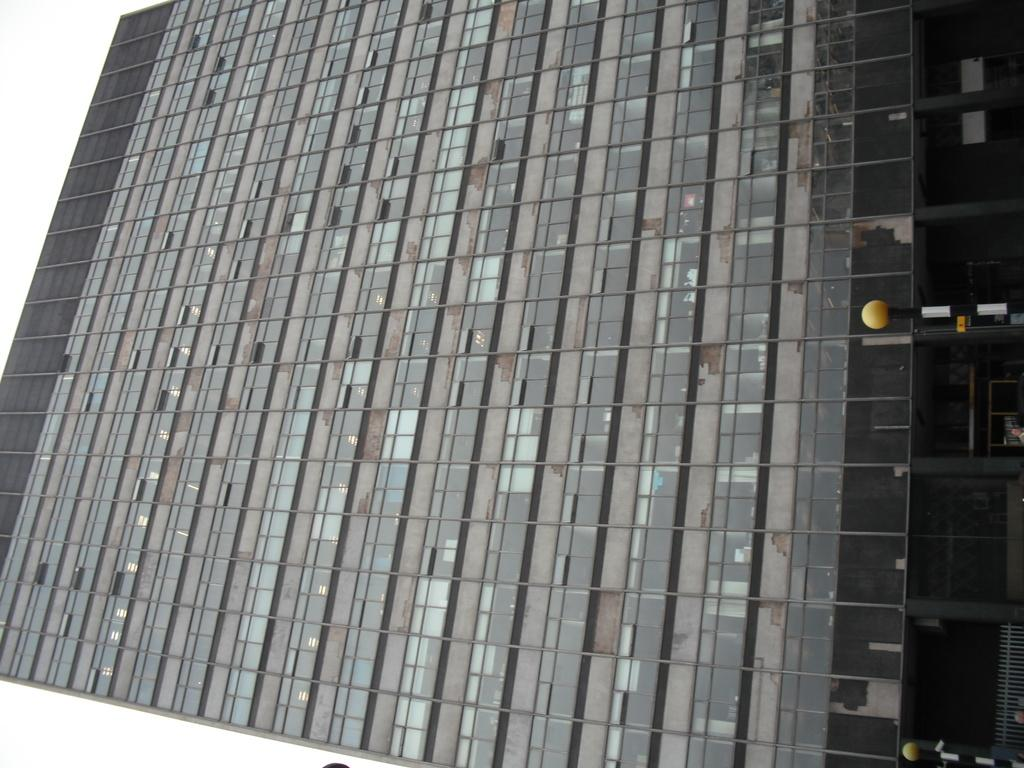What type of structure is visible on the left side of the image? There is a building on the left side of the image. Can you describe the location of the building in the image? The building is on the left side of the image. What other objects can be seen on the right side of the image? There are two poles on the right side of the image. What language is spoken by the heart in the image? There is no heart present in the image, and therefore no language can be attributed to it. 